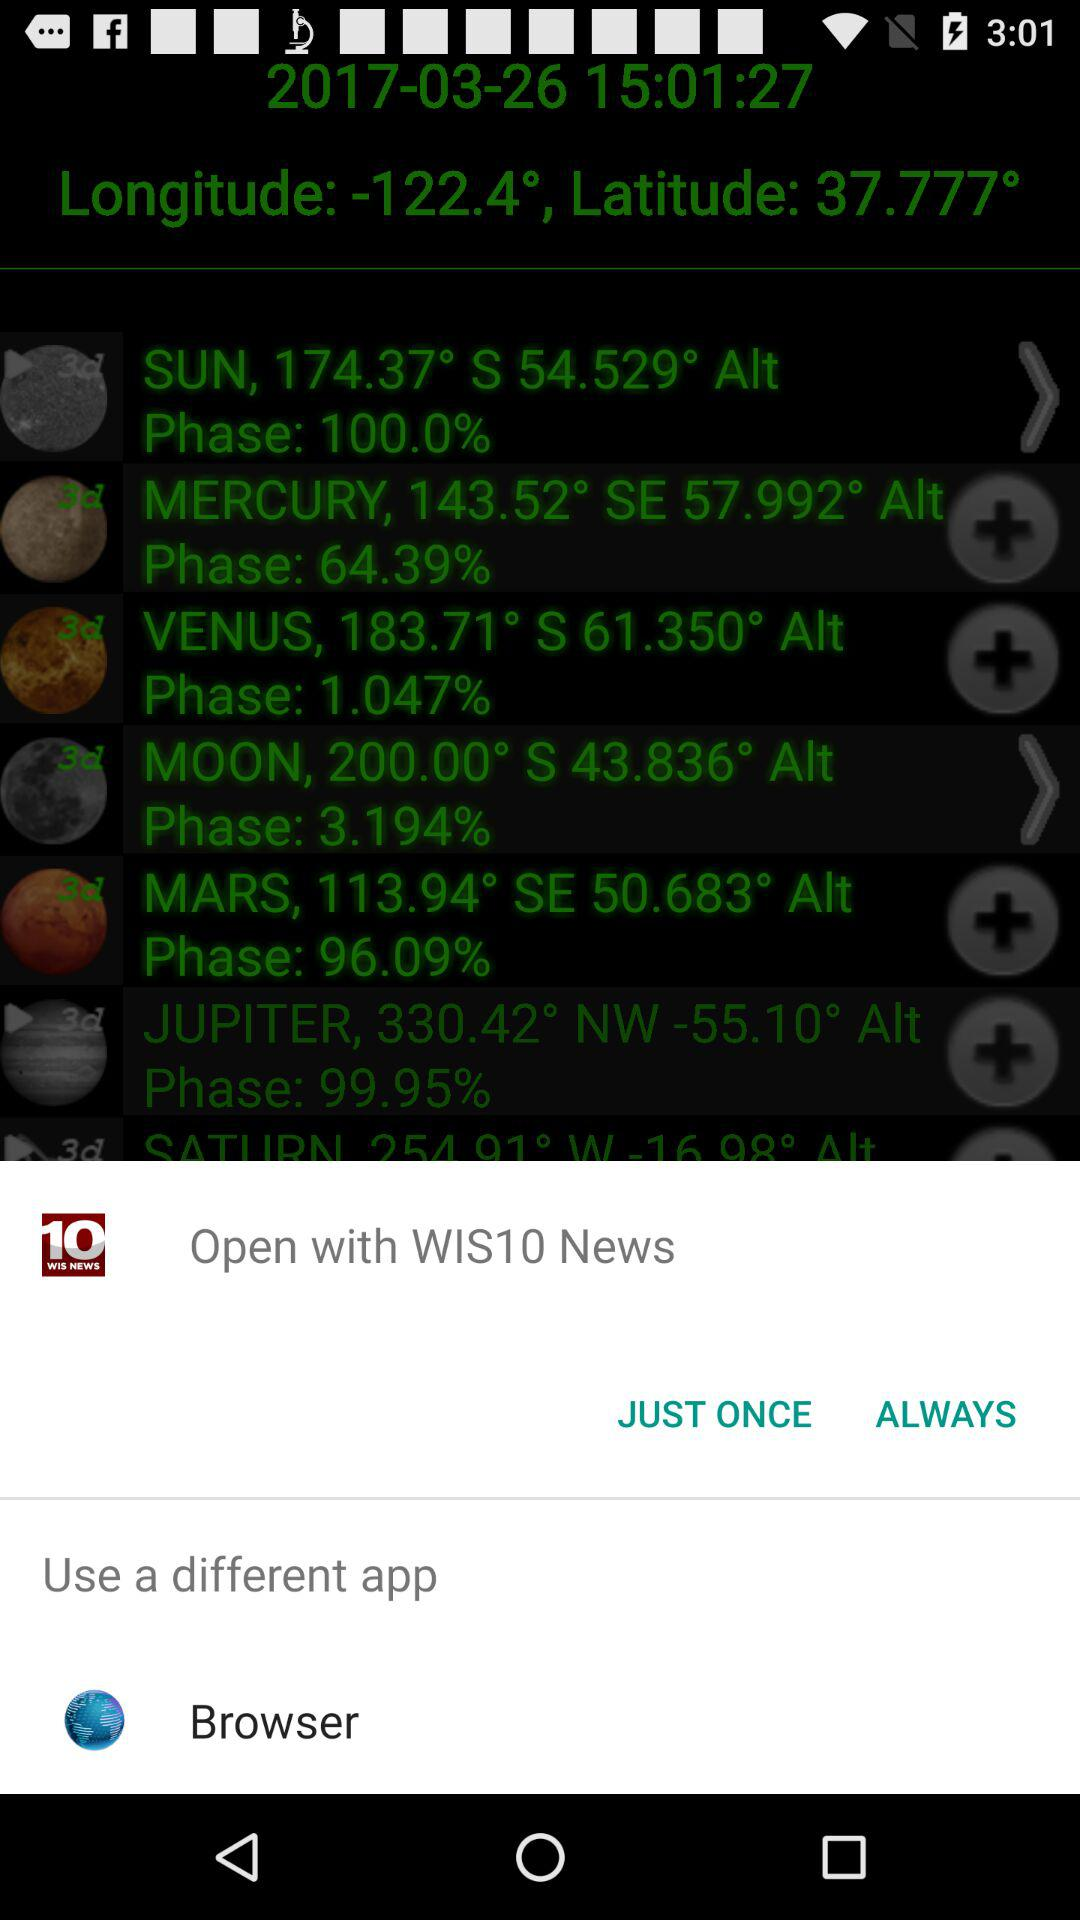Through what applications can we open? We can open through "WIS10 News" and "Browser". 